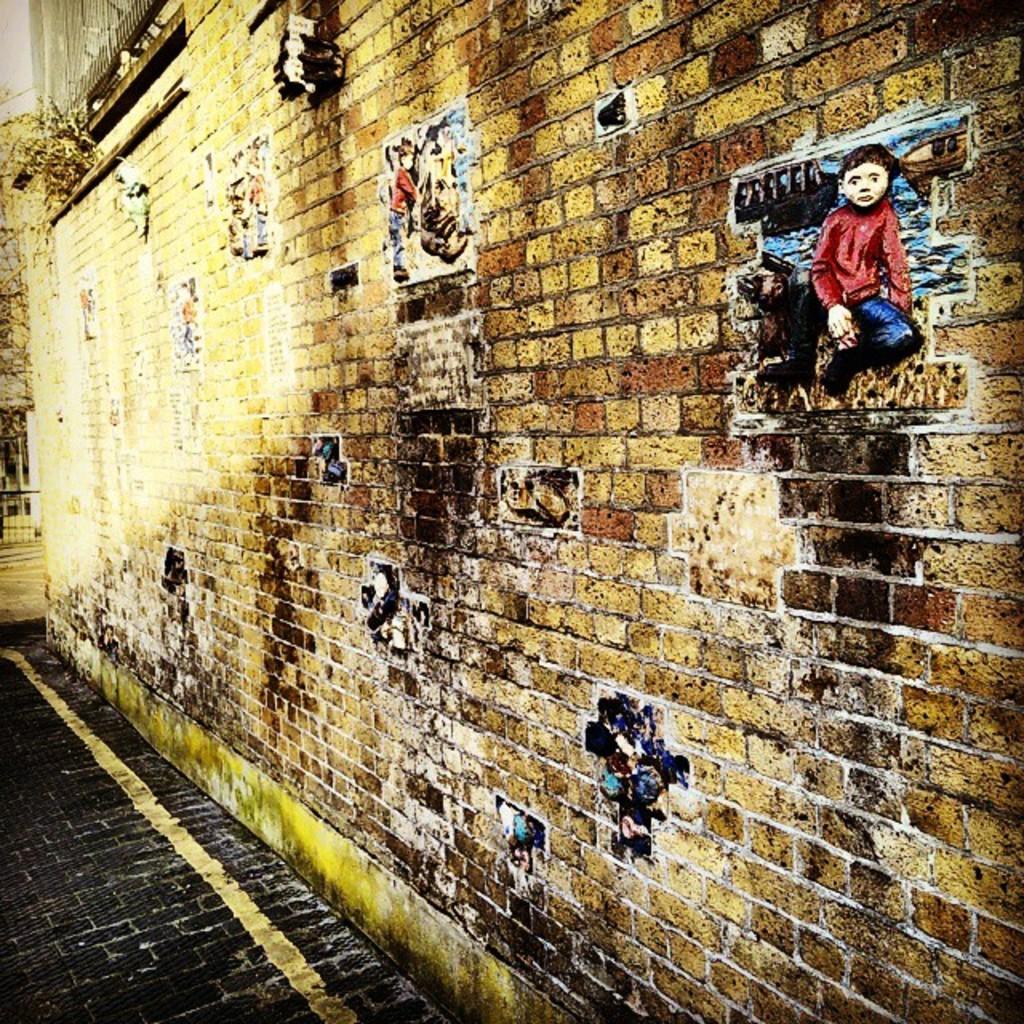Could you give a brief overview of what you see in this image? In this picture we can see the ground, beside this ground we can see posts on the wall. 